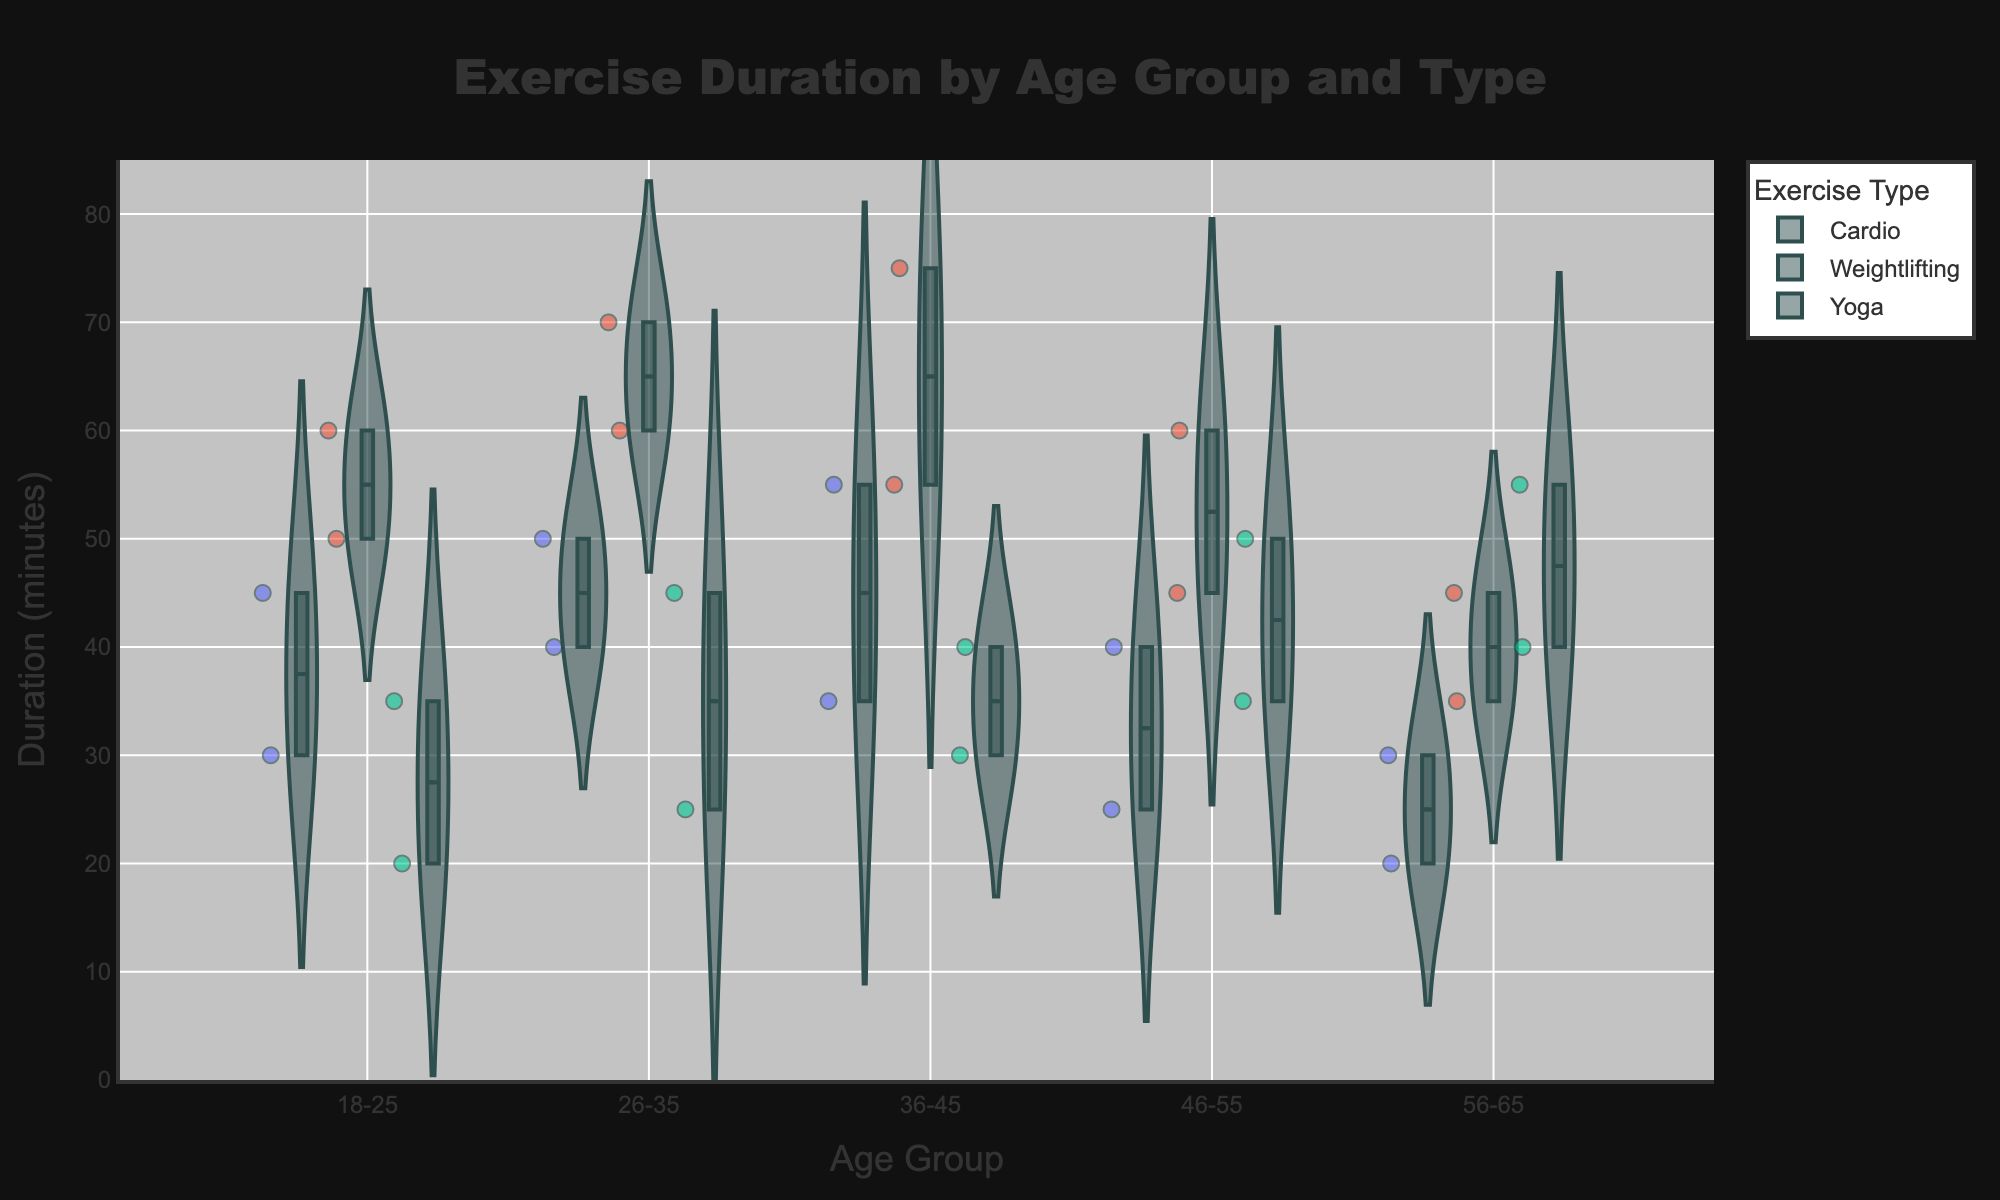What is the range of the y-axis? The y-axis shows the exercise duration in minutes. Upon inspection, it ranges from 0 to a little over the maximum duration present. By looking at the chart, we can see that the highest value point is around 75 minutes, so adding a buffer for visibility, we can estimate the range as 0 to 80 minutes.
Answer: 0 to 80 minutes Which age group has the highest median duration for Weightlifting? To find this, we look at the boxplot line within each violin plot for Weightlifting in each age group. The 36-45 age group has the highest median duration, which appears to be around 75 minutes.
Answer: 36-45 How does the average duration of Cardio exercises in the 56-65 age group compare to that in the 18-25 age group? First, locate the jittered points and box in the Cardio violin plots for both age groups. The points and box in the 56-65 group center around 25 minutes, while those in the 18-25 group center around 37.5 minutes. The average duration for Cardio is higher in the 18-25 age group.
Answer: 18-25 is higher In which age group is the variability of exercise duration the highest for Yoga? Variability in a violin plot can be assessed by looking at the width and spread of the areas. The wider and more spread out the plot, the higher the variability. For Yoga, the 56-65 age group shows a wider and more spread area, indicating the highest variability.
Answer: 56-65 What is the title of the chart? The title is at the top center of the chart. It reads "Exercise Duration by Age Group and Type".
Answer: Exercise Duration by Age Group and Type Which exercise type generally has the longest average duration across all age groups? By observing the density and location of the points and boxplots for each exercise type across all age groups, Weightlifting consistently shows higher median and average values compared to Cardio and Yoga.
Answer: Weightlifting Are there any trends in exercise duration as age increases? To identify trends, observe the overall distribution of exercise durations for different age groups. For Cardio, durations tend to decrease with age. For Weightlifting, there is a general increase up to 36-45, then a decrease. For Yoga, there is more variability, but older groups seem to have longer durations on average.
Answer: Cardio decreases, Weightlifting peaks at 36-45, Yoga varies What is the median duration for Yoga in the 26-35 age group? Look at the boxplot within the Yoga violin plot for the 26-35 age group. The median is represented by the central line in the box and appears at around 35-40 minutes.
Answer: 35-40 minutes 